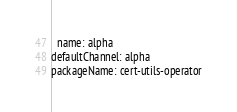<code> <loc_0><loc_0><loc_500><loc_500><_YAML_>  name: alpha
defaultChannel: alpha
packageName: cert-utils-operator
</code> 